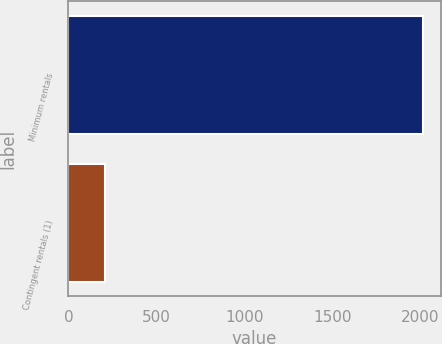Convert chart. <chart><loc_0><loc_0><loc_500><loc_500><bar_chart><fcel>Minimum rentals<fcel>Contingent rentals (1)<nl><fcel>2018<fcel>210<nl></chart> 